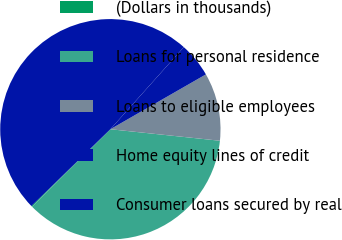Convert chart to OTSL. <chart><loc_0><loc_0><loc_500><loc_500><pie_chart><fcel>(Dollars in thousands)<fcel>Loans for personal residence<fcel>Loans to eligible employees<fcel>Home equity lines of credit<fcel>Consumer loans secured by real<nl><fcel>0.14%<fcel>35.91%<fcel>9.96%<fcel>5.09%<fcel>48.89%<nl></chart> 